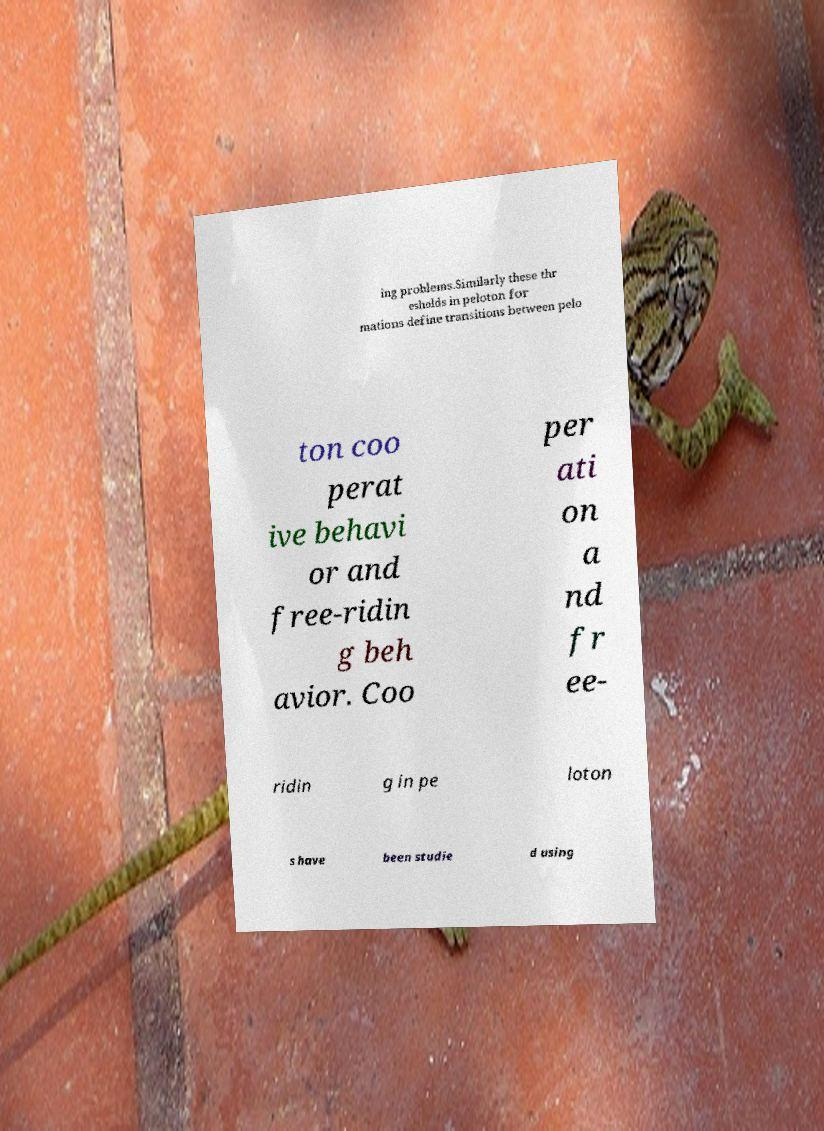For documentation purposes, I need the text within this image transcribed. Could you provide that? ing problems.Similarly these thr esholds in peloton for mations define transitions between pelo ton coo perat ive behavi or and free-ridin g beh avior. Coo per ati on a nd fr ee- ridin g in pe loton s have been studie d using 